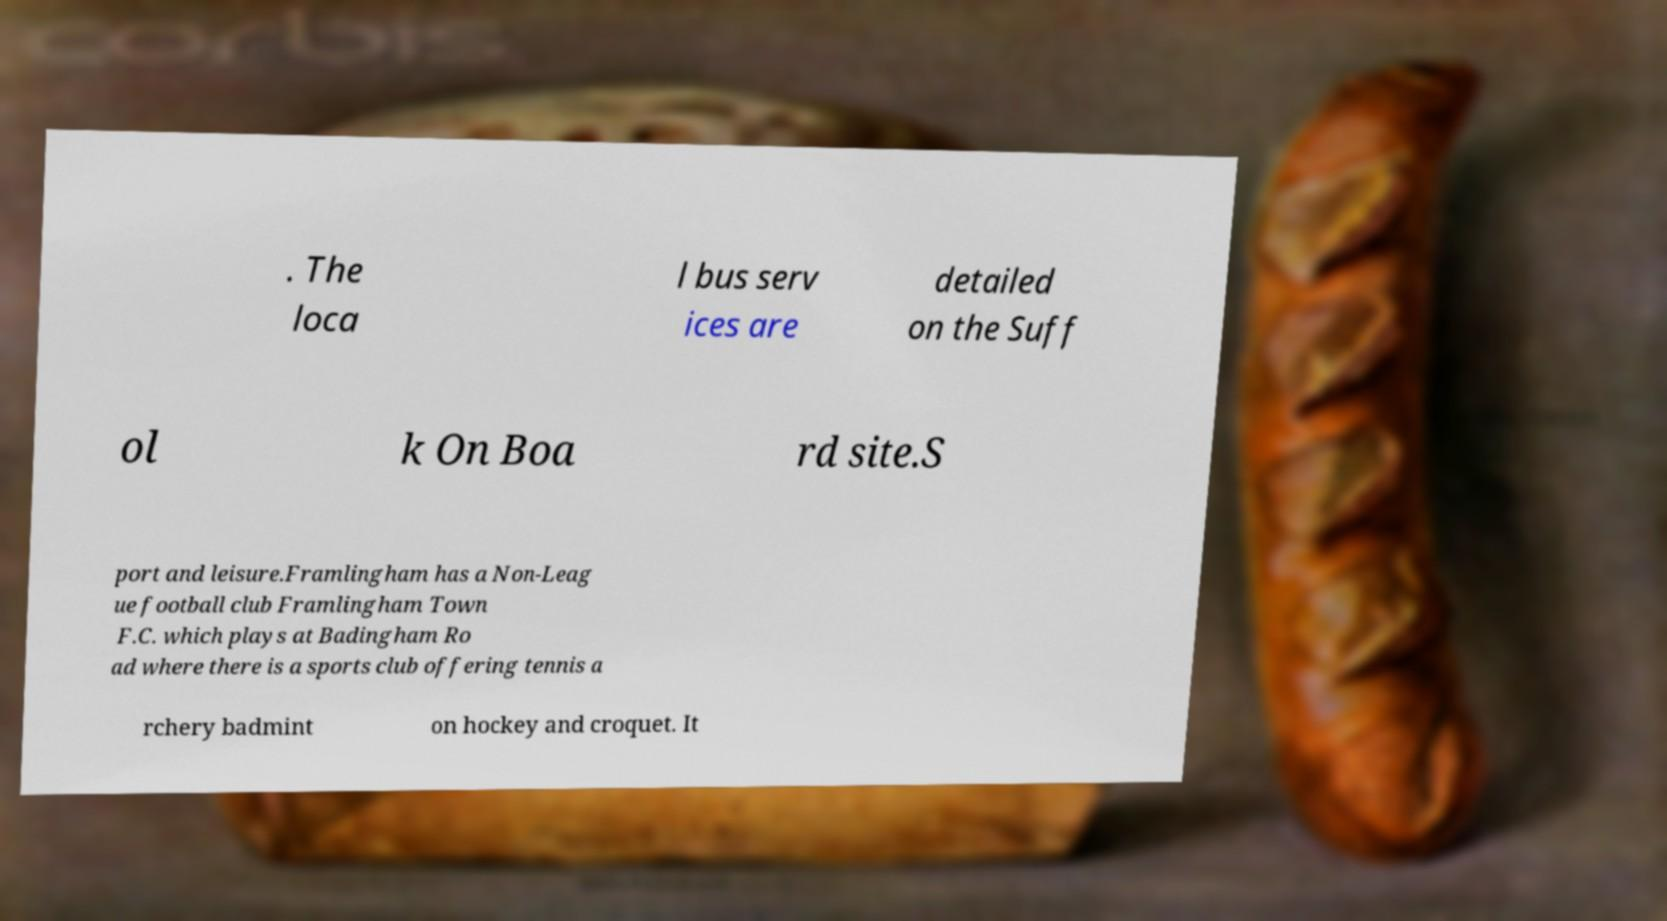Please identify and transcribe the text found in this image. . The loca l bus serv ices are detailed on the Suff ol k On Boa rd site.S port and leisure.Framlingham has a Non-Leag ue football club Framlingham Town F.C. which plays at Badingham Ro ad where there is a sports club offering tennis a rchery badmint on hockey and croquet. It 